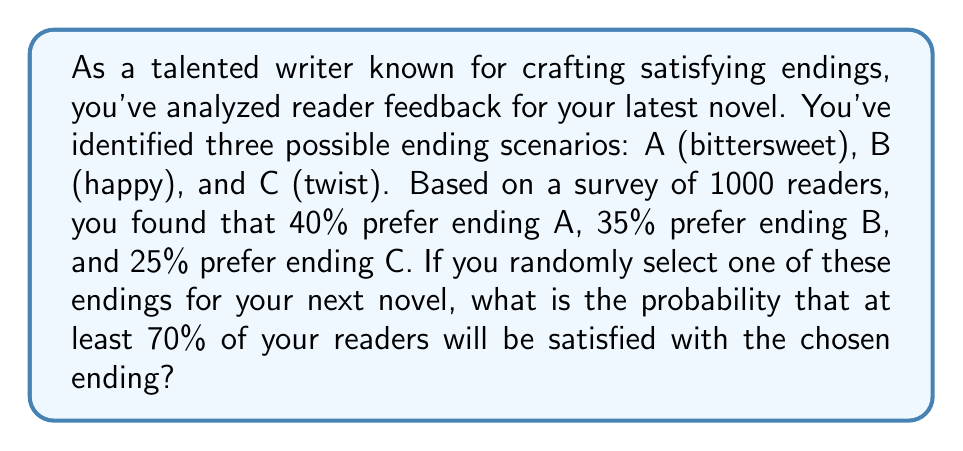Solve this math problem. Let's approach this step-by-step:

1) First, we need to understand what "at least 70% of readers being satisfied" means for each ending:

   For ending A: At least 700 out of 1000 readers should prefer A
   For ending B: At least 700 out of 1000 readers should prefer B
   For ending C: At least 700 out of 1000 readers should prefer C

2) We can see that none of the endings satisfy this condition individually. Therefore, the probability of satisfying at least 70% of readers with any ending is 0.

3) To calculate this mathematically:

   P(A) = 0.40 < 0.70
   P(B) = 0.35 < 0.70
   P(C) = 0.25 < 0.70

4) The probability of satisfying at least 70% of readers is:

   P(satisfying ≥ 70%) = P(A ≥ 0.70 or B ≥ 0.70 or C ≥ 0.70)
                       = P(A ≥ 0.70) + P(B ≥ 0.70) + P(C ≥ 0.70)
                       = 0 + 0 + 0 = 0

5) Therefore, the probability of satisfying at least 70% of readers with a randomly chosen ending is 0.
Answer: 0 